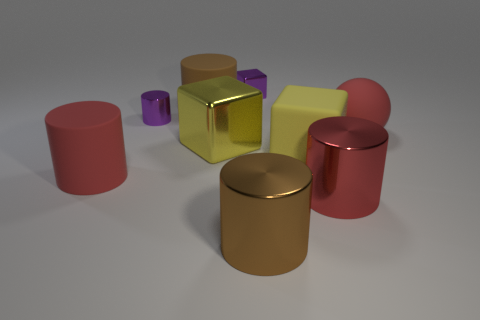Are there any objects that seem out of place or different from the rest? All objects share a simple geometric shape and smooth surface, making them part of a cohesive set. However, in terms of size, the small purple objects stand out for being noticeably smaller than the others. 